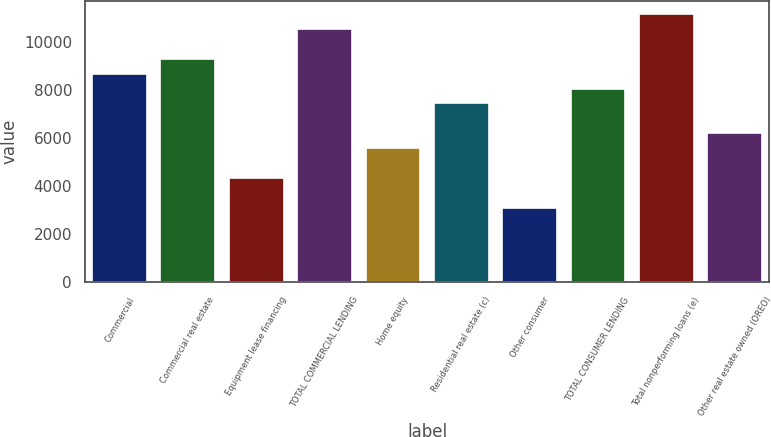Convert chart to OTSL. <chart><loc_0><loc_0><loc_500><loc_500><bar_chart><fcel>Commercial<fcel>Commercial real estate<fcel>Equipment lease financing<fcel>TOTAL COMMERCIAL LENDING<fcel>Home equity<fcel>Residential real estate (c)<fcel>Other consumer<fcel>TOTAL CONSUMER LENDING<fcel>Total nonperforming loans (e)<fcel>Other real estate owned (OREO)<nl><fcel>8684.93<fcel>9305.16<fcel>4343.32<fcel>10545.6<fcel>5583.78<fcel>7444.47<fcel>3102.86<fcel>8064.7<fcel>11165.9<fcel>6204.01<nl></chart> 